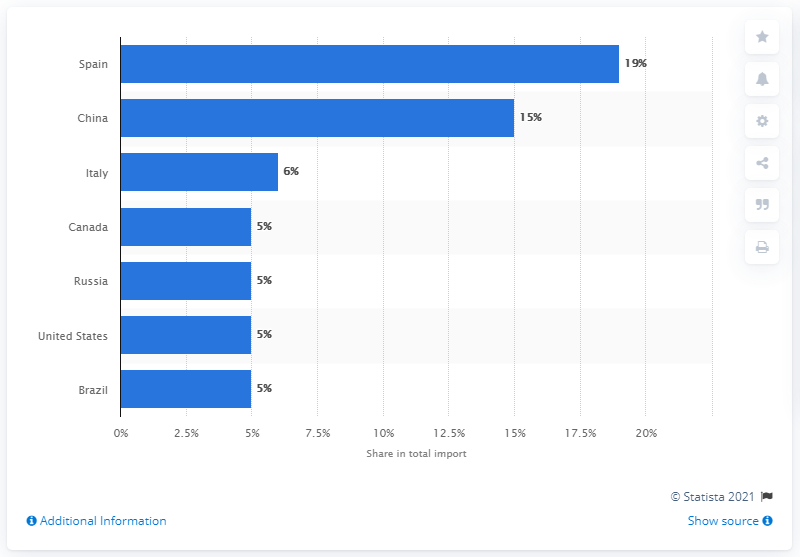Give some essential details in this illustration. In 2019, Cuba's most important import partner was Spain. 